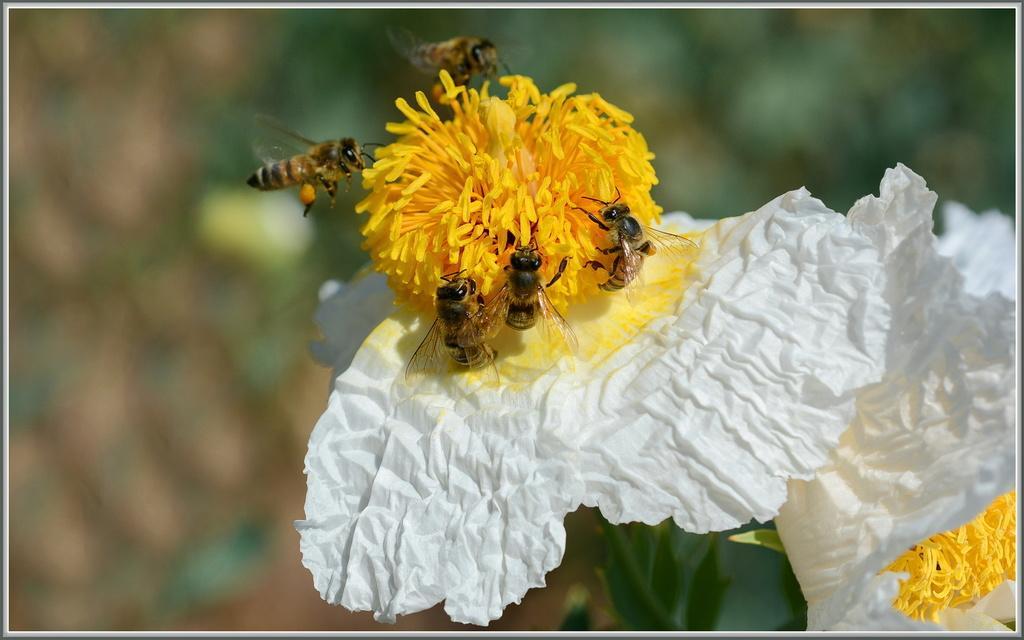Could you give a brief overview of what you see in this image? In this picture we can see white and yellow color flower on which five honey bees are sitting on it. Behind we can see a blur background. 